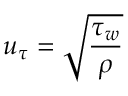<formula> <loc_0><loc_0><loc_500><loc_500>u _ { \tau } = \sqrt { \frac { \tau _ { w } } { \rho } }</formula> 